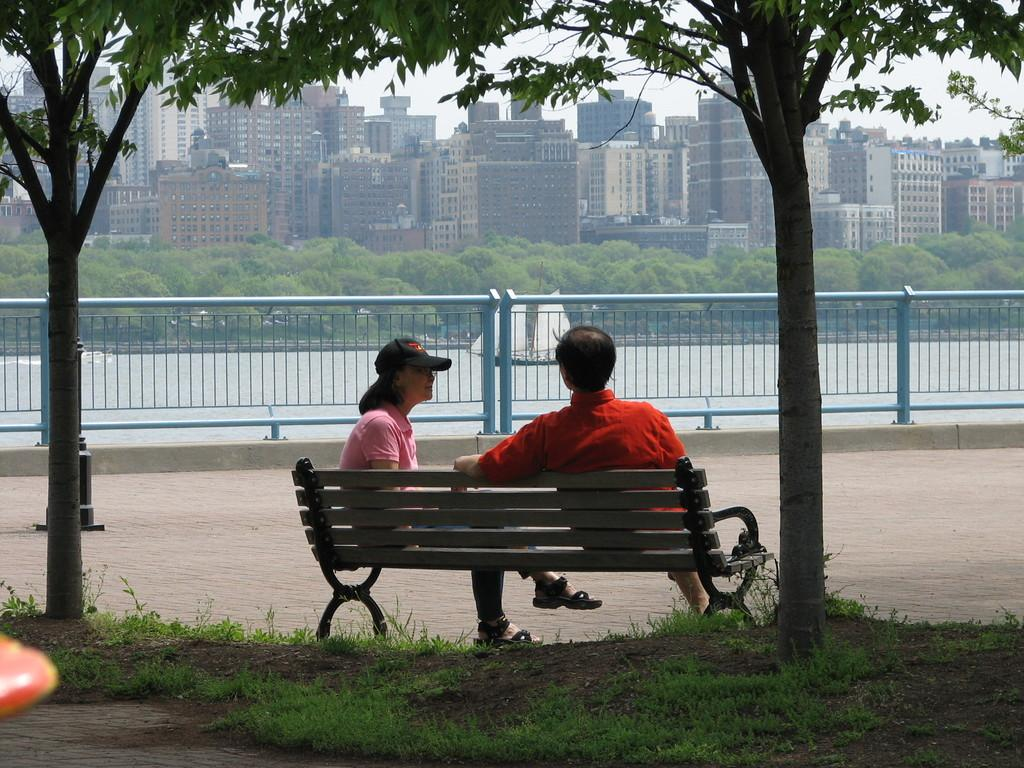How many people are sitting on the bench in the image? There are two persons sitting on a bench in the image. What is behind the bench? There is grass behind the bench. What is in front of the bench? There are buildings, trees, and a boat in the water in front of the bench. Can you tell me how many geese are swimming in the water near the boat? There are no geese present in the image; it only features a boat in the water. What type of question is the secretary asking the persons sitting on the bench? There is no secretary present in the image, so it is not possible to answer that question. 